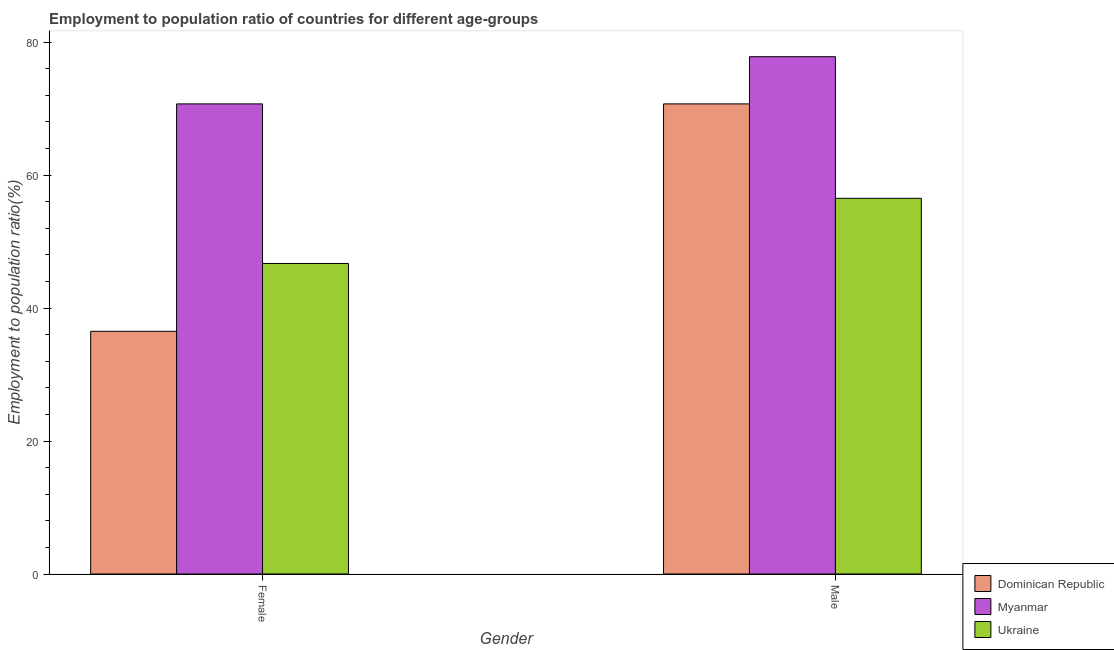How many groups of bars are there?
Keep it short and to the point. 2. Are the number of bars on each tick of the X-axis equal?
Offer a very short reply. Yes. How many bars are there on the 1st tick from the right?
Provide a short and direct response. 3. What is the employment to population ratio(male) in Dominican Republic?
Provide a short and direct response. 70.7. Across all countries, what is the maximum employment to population ratio(male)?
Make the answer very short. 77.8. Across all countries, what is the minimum employment to population ratio(male)?
Provide a succinct answer. 56.5. In which country was the employment to population ratio(male) maximum?
Keep it short and to the point. Myanmar. In which country was the employment to population ratio(female) minimum?
Your answer should be compact. Dominican Republic. What is the total employment to population ratio(male) in the graph?
Offer a terse response. 205. What is the difference between the employment to population ratio(female) in Ukraine and that in Myanmar?
Offer a very short reply. -24. What is the average employment to population ratio(male) per country?
Offer a very short reply. 68.33. What is the difference between the employment to population ratio(male) and employment to population ratio(female) in Dominican Republic?
Make the answer very short. 34.2. In how many countries, is the employment to population ratio(male) greater than 8 %?
Provide a succinct answer. 3. What is the ratio of the employment to population ratio(female) in Myanmar to that in Ukraine?
Provide a short and direct response. 1.51. Is the employment to population ratio(female) in Myanmar less than that in Dominican Republic?
Keep it short and to the point. No. In how many countries, is the employment to population ratio(female) greater than the average employment to population ratio(female) taken over all countries?
Offer a terse response. 1. What does the 3rd bar from the left in Female represents?
Your answer should be very brief. Ukraine. What does the 2nd bar from the right in Male represents?
Provide a short and direct response. Myanmar. How many bars are there?
Your answer should be very brief. 6. What is the difference between two consecutive major ticks on the Y-axis?
Offer a terse response. 20. Are the values on the major ticks of Y-axis written in scientific E-notation?
Provide a succinct answer. No. Does the graph contain any zero values?
Keep it short and to the point. No. Where does the legend appear in the graph?
Offer a very short reply. Bottom right. How are the legend labels stacked?
Offer a very short reply. Vertical. What is the title of the graph?
Offer a very short reply. Employment to population ratio of countries for different age-groups. Does "St. Martin (French part)" appear as one of the legend labels in the graph?
Make the answer very short. No. What is the label or title of the X-axis?
Your response must be concise. Gender. What is the Employment to population ratio(%) in Dominican Republic in Female?
Your answer should be very brief. 36.5. What is the Employment to population ratio(%) of Myanmar in Female?
Give a very brief answer. 70.7. What is the Employment to population ratio(%) of Ukraine in Female?
Give a very brief answer. 46.7. What is the Employment to population ratio(%) of Dominican Republic in Male?
Your answer should be compact. 70.7. What is the Employment to population ratio(%) in Myanmar in Male?
Provide a succinct answer. 77.8. What is the Employment to population ratio(%) in Ukraine in Male?
Give a very brief answer. 56.5. Across all Gender, what is the maximum Employment to population ratio(%) in Dominican Republic?
Give a very brief answer. 70.7. Across all Gender, what is the maximum Employment to population ratio(%) in Myanmar?
Keep it short and to the point. 77.8. Across all Gender, what is the maximum Employment to population ratio(%) of Ukraine?
Keep it short and to the point. 56.5. Across all Gender, what is the minimum Employment to population ratio(%) in Dominican Republic?
Ensure brevity in your answer.  36.5. Across all Gender, what is the minimum Employment to population ratio(%) of Myanmar?
Ensure brevity in your answer.  70.7. Across all Gender, what is the minimum Employment to population ratio(%) in Ukraine?
Give a very brief answer. 46.7. What is the total Employment to population ratio(%) in Dominican Republic in the graph?
Keep it short and to the point. 107.2. What is the total Employment to population ratio(%) of Myanmar in the graph?
Give a very brief answer. 148.5. What is the total Employment to population ratio(%) in Ukraine in the graph?
Your answer should be compact. 103.2. What is the difference between the Employment to population ratio(%) of Dominican Republic in Female and that in Male?
Offer a terse response. -34.2. What is the difference between the Employment to population ratio(%) in Ukraine in Female and that in Male?
Provide a succinct answer. -9.8. What is the difference between the Employment to population ratio(%) in Dominican Republic in Female and the Employment to population ratio(%) in Myanmar in Male?
Offer a terse response. -41.3. What is the average Employment to population ratio(%) of Dominican Republic per Gender?
Your answer should be compact. 53.6. What is the average Employment to population ratio(%) of Myanmar per Gender?
Your answer should be compact. 74.25. What is the average Employment to population ratio(%) in Ukraine per Gender?
Offer a very short reply. 51.6. What is the difference between the Employment to population ratio(%) of Dominican Republic and Employment to population ratio(%) of Myanmar in Female?
Provide a short and direct response. -34.2. What is the difference between the Employment to population ratio(%) of Myanmar and Employment to population ratio(%) of Ukraine in Female?
Give a very brief answer. 24. What is the difference between the Employment to population ratio(%) in Dominican Republic and Employment to population ratio(%) in Myanmar in Male?
Offer a very short reply. -7.1. What is the difference between the Employment to population ratio(%) in Myanmar and Employment to population ratio(%) in Ukraine in Male?
Your answer should be very brief. 21.3. What is the ratio of the Employment to population ratio(%) of Dominican Republic in Female to that in Male?
Keep it short and to the point. 0.52. What is the ratio of the Employment to population ratio(%) in Myanmar in Female to that in Male?
Your response must be concise. 0.91. What is the ratio of the Employment to population ratio(%) of Ukraine in Female to that in Male?
Your answer should be very brief. 0.83. What is the difference between the highest and the second highest Employment to population ratio(%) in Dominican Republic?
Provide a short and direct response. 34.2. What is the difference between the highest and the second highest Employment to population ratio(%) in Myanmar?
Provide a succinct answer. 7.1. What is the difference between the highest and the lowest Employment to population ratio(%) of Dominican Republic?
Provide a short and direct response. 34.2. What is the difference between the highest and the lowest Employment to population ratio(%) of Myanmar?
Your answer should be very brief. 7.1. 